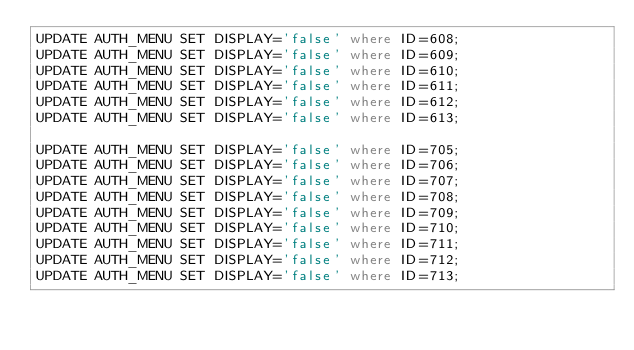Convert code to text. <code><loc_0><loc_0><loc_500><loc_500><_SQL_>UPDATE AUTH_MENU SET DISPLAY='false' where ID=608;
UPDATE AUTH_MENU SET DISPLAY='false' where ID=609;
UPDATE AUTH_MENU SET DISPLAY='false' where ID=610;
UPDATE AUTH_MENU SET DISPLAY='false' where ID=611;
UPDATE AUTH_MENU SET DISPLAY='false' where ID=612;
UPDATE AUTH_MENU SET DISPLAY='false' where ID=613;

UPDATE AUTH_MENU SET DISPLAY='false' where ID=705;
UPDATE AUTH_MENU SET DISPLAY='false' where ID=706;
UPDATE AUTH_MENU SET DISPLAY='false' where ID=707;
UPDATE AUTH_MENU SET DISPLAY='false' where ID=708;
UPDATE AUTH_MENU SET DISPLAY='false' where ID=709;
UPDATE AUTH_MENU SET DISPLAY='false' where ID=710;
UPDATE AUTH_MENU SET DISPLAY='false' where ID=711;
UPDATE AUTH_MENU SET DISPLAY='false' where ID=712;
UPDATE AUTH_MENU SET DISPLAY='false' where ID=713;

</code> 